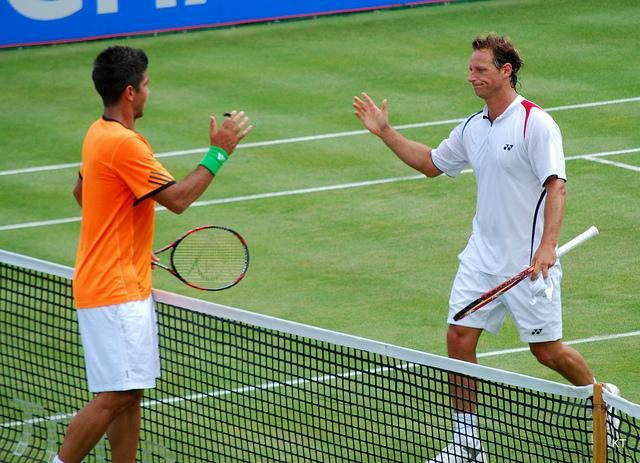What is the name of a famous player of this sport?

Choices:
A) johnson
B) sampras
C) botham
D) rooney sampras 